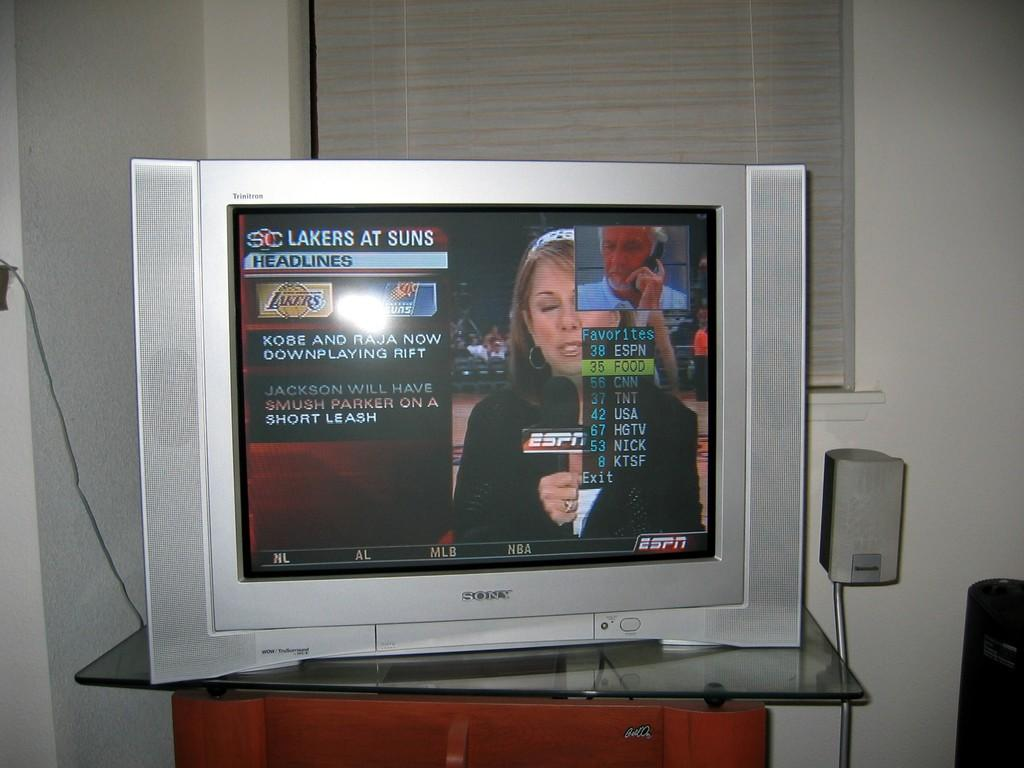<image>
Render a clear and concise summary of the photo. a sony trinitron with a game on of the lakers at suns 